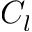Convert formula to latex. <formula><loc_0><loc_0><loc_500><loc_500>C _ { l }</formula> 